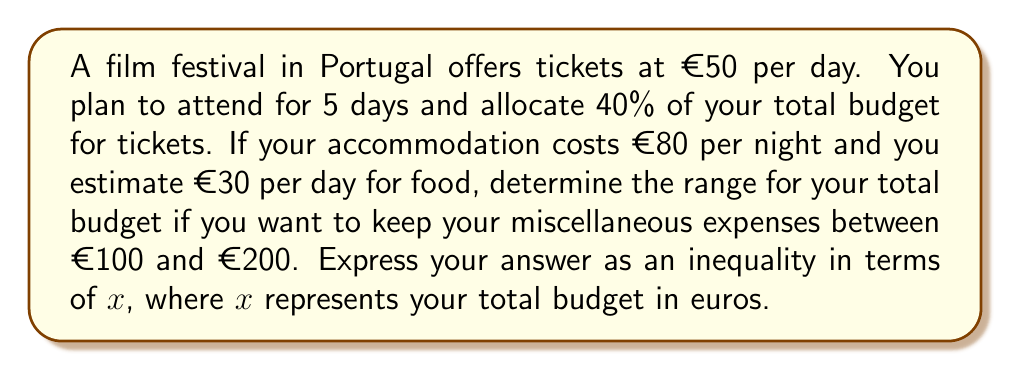What is the answer to this math problem? Let's break this down step-by-step:

1) First, calculate the total cost of festival tickets:
   €50 × 5 days = €250

2) This €250 represents 40% of the total budget. Let's express this mathematically:
   $0.4x = 250$, where x is the total budget

3) Calculate accommodation costs:
   €80 × 5 nights = €400

4) Calculate food costs:
   €30 × 5 days = €150

5) Now, let's set up our inequality. The total budget (x) should be greater than or equal to the sum of tickets, accommodation, food, and minimum miscellaneous expenses, and less than or equal to the sum with maximum miscellaneous expenses:

   $250 + 400 + 150 + 100 \leq x \leq 250 + 400 + 150 + 200$

6) Simplify:
   $900 \leq x \leq 1000$

7) Remember, we calculated that $0.4x = 250$ in step 2. Let's solve this for x:
   $x = 250 / 0.4 = 625$

8) Our final inequality should include this condition:
   $900 \leq x \leq 1000$ and $x = 625$

9) Combining these conditions, we get:
   $900 \leq 625 \leq x \leq 1000$
Answer: $900 \leq 625 \leq x \leq 1000$ 